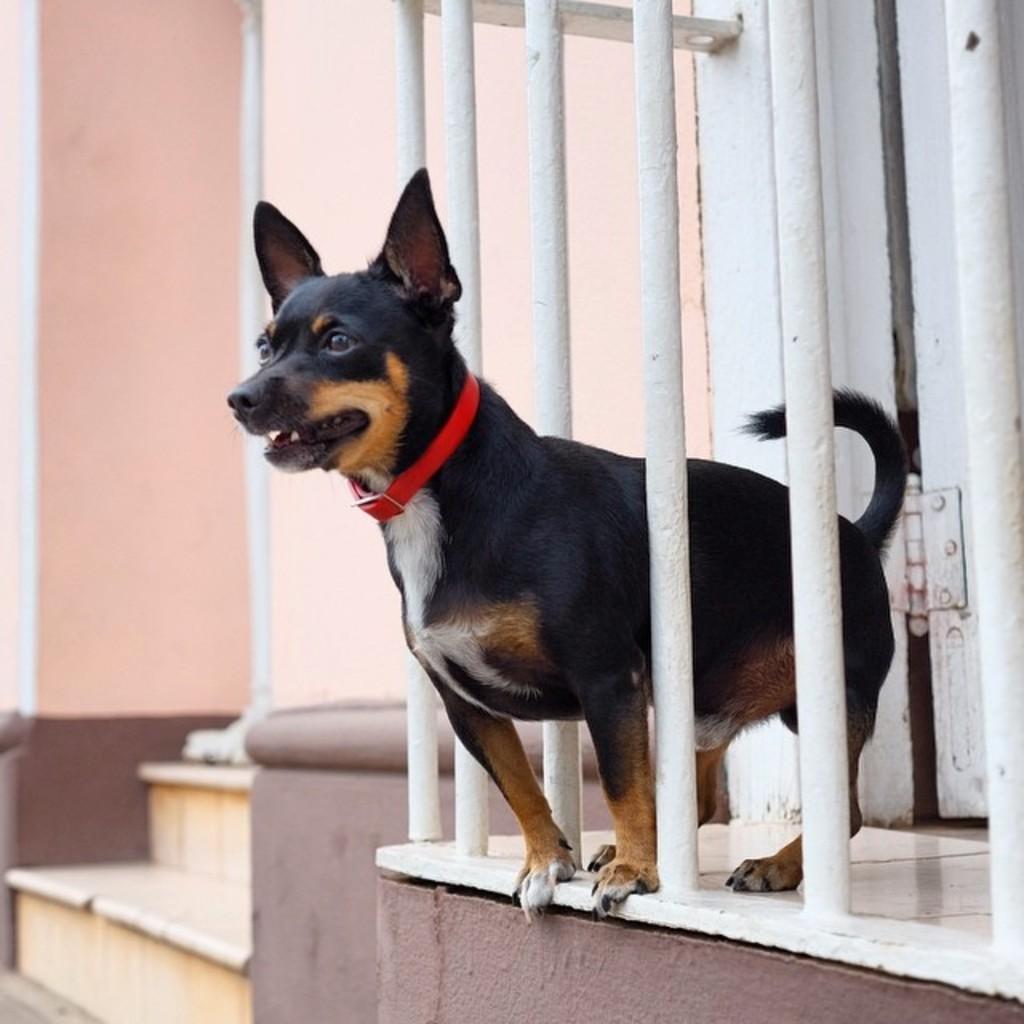Could you give a brief overview of what you see in this image? In this image I can see a fence and through fence I can see a dog and I can see a staircase on the left side and I can see the wall on the left side. 